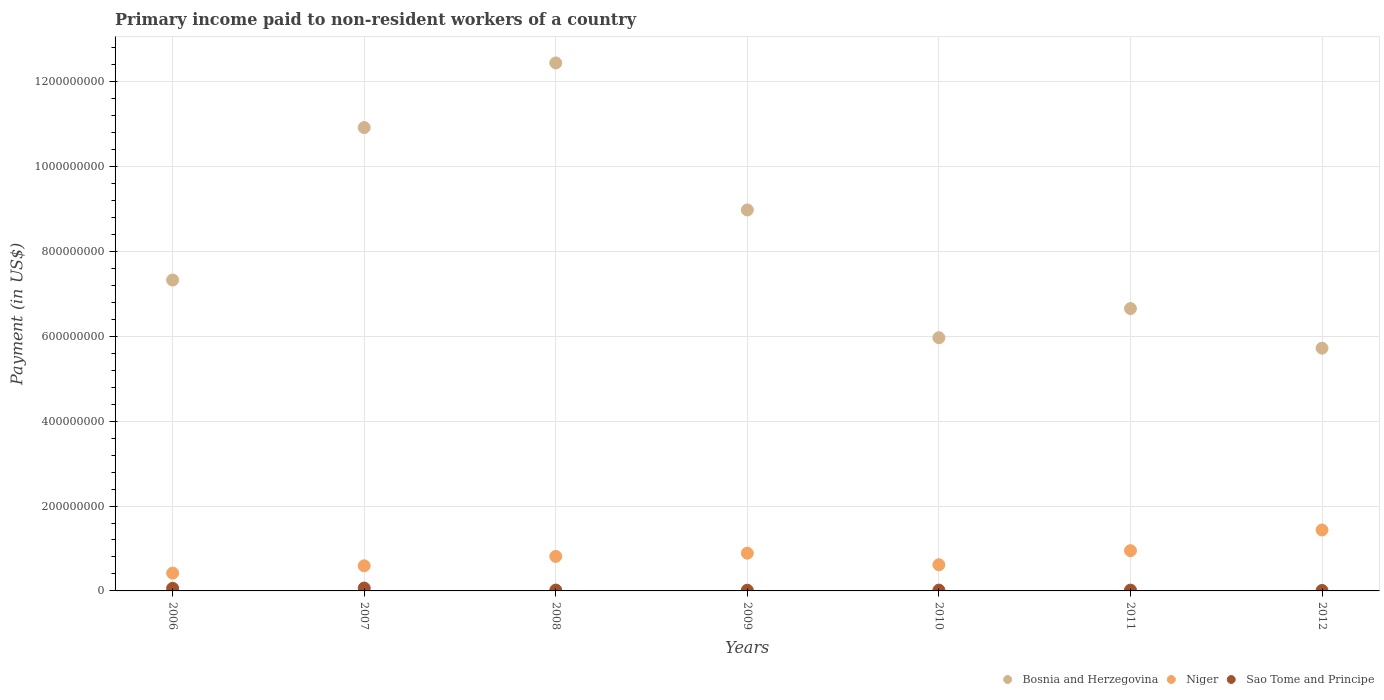How many different coloured dotlines are there?
Your answer should be compact. 3. What is the amount paid to workers in Niger in 2006?
Ensure brevity in your answer.  4.20e+07. Across all years, what is the maximum amount paid to workers in Bosnia and Herzegovina?
Provide a short and direct response. 1.24e+09. Across all years, what is the minimum amount paid to workers in Niger?
Give a very brief answer. 4.20e+07. In which year was the amount paid to workers in Niger minimum?
Make the answer very short. 2006. What is the total amount paid to workers in Bosnia and Herzegovina in the graph?
Your answer should be very brief. 5.80e+09. What is the difference between the amount paid to workers in Niger in 2006 and that in 2011?
Your response must be concise. -5.28e+07. What is the difference between the amount paid to workers in Niger in 2006 and the amount paid to workers in Bosnia and Herzegovina in 2009?
Your answer should be compact. -8.56e+08. What is the average amount paid to workers in Sao Tome and Principe per year?
Your answer should be very brief. 3.04e+06. In the year 2009, what is the difference between the amount paid to workers in Niger and amount paid to workers in Bosnia and Herzegovina?
Provide a succinct answer. -8.09e+08. What is the ratio of the amount paid to workers in Sao Tome and Principe in 2008 to that in 2011?
Make the answer very short. 1.04. Is the difference between the amount paid to workers in Niger in 2009 and 2011 greater than the difference between the amount paid to workers in Bosnia and Herzegovina in 2009 and 2011?
Give a very brief answer. No. What is the difference between the highest and the second highest amount paid to workers in Sao Tome and Principe?
Offer a very short reply. 6.11e+05. What is the difference between the highest and the lowest amount paid to workers in Niger?
Offer a terse response. 1.02e+08. In how many years, is the amount paid to workers in Bosnia and Herzegovina greater than the average amount paid to workers in Bosnia and Herzegovina taken over all years?
Give a very brief answer. 3. Is the sum of the amount paid to workers in Bosnia and Herzegovina in 2007 and 2008 greater than the maximum amount paid to workers in Niger across all years?
Offer a terse response. Yes. Does the graph contain grids?
Ensure brevity in your answer.  Yes. Where does the legend appear in the graph?
Give a very brief answer. Bottom right. How are the legend labels stacked?
Offer a terse response. Horizontal. What is the title of the graph?
Your response must be concise. Primary income paid to non-resident workers of a country. Does "Somalia" appear as one of the legend labels in the graph?
Keep it short and to the point. No. What is the label or title of the X-axis?
Your response must be concise. Years. What is the label or title of the Y-axis?
Offer a terse response. Payment (in US$). What is the Payment (in US$) in Bosnia and Herzegovina in 2006?
Offer a very short reply. 7.33e+08. What is the Payment (in US$) of Niger in 2006?
Offer a terse response. 4.20e+07. What is the Payment (in US$) in Sao Tome and Principe in 2006?
Provide a succinct answer. 6.15e+06. What is the Payment (in US$) in Bosnia and Herzegovina in 2007?
Provide a short and direct response. 1.09e+09. What is the Payment (in US$) in Niger in 2007?
Your answer should be compact. 5.92e+07. What is the Payment (in US$) in Sao Tome and Principe in 2007?
Give a very brief answer. 6.76e+06. What is the Payment (in US$) in Bosnia and Herzegovina in 2008?
Make the answer very short. 1.24e+09. What is the Payment (in US$) of Niger in 2008?
Offer a very short reply. 8.13e+07. What is the Payment (in US$) in Sao Tome and Principe in 2008?
Ensure brevity in your answer.  1.94e+06. What is the Payment (in US$) in Bosnia and Herzegovina in 2009?
Offer a very short reply. 8.98e+08. What is the Payment (in US$) of Niger in 2009?
Give a very brief answer. 8.89e+07. What is the Payment (in US$) of Sao Tome and Principe in 2009?
Your response must be concise. 1.64e+06. What is the Payment (in US$) of Bosnia and Herzegovina in 2010?
Offer a terse response. 5.97e+08. What is the Payment (in US$) of Niger in 2010?
Offer a terse response. 6.17e+07. What is the Payment (in US$) in Sao Tome and Principe in 2010?
Make the answer very short. 1.89e+06. What is the Payment (in US$) in Bosnia and Herzegovina in 2011?
Your answer should be compact. 6.65e+08. What is the Payment (in US$) of Niger in 2011?
Your answer should be very brief. 9.48e+07. What is the Payment (in US$) in Sao Tome and Principe in 2011?
Your answer should be very brief. 1.87e+06. What is the Payment (in US$) in Bosnia and Herzegovina in 2012?
Give a very brief answer. 5.72e+08. What is the Payment (in US$) in Niger in 2012?
Ensure brevity in your answer.  1.44e+08. What is the Payment (in US$) in Sao Tome and Principe in 2012?
Offer a terse response. 1.02e+06. Across all years, what is the maximum Payment (in US$) in Bosnia and Herzegovina?
Offer a terse response. 1.24e+09. Across all years, what is the maximum Payment (in US$) of Niger?
Your response must be concise. 1.44e+08. Across all years, what is the maximum Payment (in US$) in Sao Tome and Principe?
Your answer should be very brief. 6.76e+06. Across all years, what is the minimum Payment (in US$) of Bosnia and Herzegovina?
Your answer should be very brief. 5.72e+08. Across all years, what is the minimum Payment (in US$) of Niger?
Keep it short and to the point. 4.20e+07. Across all years, what is the minimum Payment (in US$) in Sao Tome and Principe?
Ensure brevity in your answer.  1.02e+06. What is the total Payment (in US$) of Bosnia and Herzegovina in the graph?
Your answer should be compact. 5.80e+09. What is the total Payment (in US$) in Niger in the graph?
Offer a very short reply. 5.72e+08. What is the total Payment (in US$) in Sao Tome and Principe in the graph?
Make the answer very short. 2.13e+07. What is the difference between the Payment (in US$) of Bosnia and Herzegovina in 2006 and that in 2007?
Provide a short and direct response. -3.59e+08. What is the difference between the Payment (in US$) of Niger in 2006 and that in 2007?
Provide a succinct answer. -1.72e+07. What is the difference between the Payment (in US$) in Sao Tome and Principe in 2006 and that in 2007?
Offer a terse response. -6.11e+05. What is the difference between the Payment (in US$) of Bosnia and Herzegovina in 2006 and that in 2008?
Your answer should be compact. -5.12e+08. What is the difference between the Payment (in US$) of Niger in 2006 and that in 2008?
Give a very brief answer. -3.94e+07. What is the difference between the Payment (in US$) in Sao Tome and Principe in 2006 and that in 2008?
Ensure brevity in your answer.  4.21e+06. What is the difference between the Payment (in US$) of Bosnia and Herzegovina in 2006 and that in 2009?
Offer a very short reply. -1.65e+08. What is the difference between the Payment (in US$) in Niger in 2006 and that in 2009?
Provide a succinct answer. -4.70e+07. What is the difference between the Payment (in US$) in Sao Tome and Principe in 2006 and that in 2009?
Keep it short and to the point. 4.51e+06. What is the difference between the Payment (in US$) in Bosnia and Herzegovina in 2006 and that in 2010?
Provide a succinct answer. 1.36e+08. What is the difference between the Payment (in US$) in Niger in 2006 and that in 2010?
Offer a terse response. -1.97e+07. What is the difference between the Payment (in US$) in Sao Tome and Principe in 2006 and that in 2010?
Make the answer very short. 4.26e+06. What is the difference between the Payment (in US$) of Bosnia and Herzegovina in 2006 and that in 2011?
Offer a very short reply. 6.72e+07. What is the difference between the Payment (in US$) in Niger in 2006 and that in 2011?
Ensure brevity in your answer.  -5.28e+07. What is the difference between the Payment (in US$) of Sao Tome and Principe in 2006 and that in 2011?
Provide a short and direct response. 4.29e+06. What is the difference between the Payment (in US$) in Bosnia and Herzegovina in 2006 and that in 2012?
Keep it short and to the point. 1.61e+08. What is the difference between the Payment (in US$) in Niger in 2006 and that in 2012?
Your answer should be very brief. -1.02e+08. What is the difference between the Payment (in US$) in Sao Tome and Principe in 2006 and that in 2012?
Offer a terse response. 5.13e+06. What is the difference between the Payment (in US$) of Bosnia and Herzegovina in 2007 and that in 2008?
Ensure brevity in your answer.  -1.52e+08. What is the difference between the Payment (in US$) in Niger in 2007 and that in 2008?
Provide a succinct answer. -2.22e+07. What is the difference between the Payment (in US$) in Sao Tome and Principe in 2007 and that in 2008?
Offer a very short reply. 4.83e+06. What is the difference between the Payment (in US$) in Bosnia and Herzegovina in 2007 and that in 2009?
Your response must be concise. 1.94e+08. What is the difference between the Payment (in US$) in Niger in 2007 and that in 2009?
Keep it short and to the point. -2.98e+07. What is the difference between the Payment (in US$) of Sao Tome and Principe in 2007 and that in 2009?
Ensure brevity in your answer.  5.12e+06. What is the difference between the Payment (in US$) in Bosnia and Herzegovina in 2007 and that in 2010?
Provide a succinct answer. 4.95e+08. What is the difference between the Payment (in US$) in Niger in 2007 and that in 2010?
Your answer should be compact. -2.50e+06. What is the difference between the Payment (in US$) of Sao Tome and Principe in 2007 and that in 2010?
Your response must be concise. 4.87e+06. What is the difference between the Payment (in US$) in Bosnia and Herzegovina in 2007 and that in 2011?
Your answer should be compact. 4.27e+08. What is the difference between the Payment (in US$) of Niger in 2007 and that in 2011?
Offer a terse response. -3.56e+07. What is the difference between the Payment (in US$) of Sao Tome and Principe in 2007 and that in 2011?
Offer a terse response. 4.90e+06. What is the difference between the Payment (in US$) of Bosnia and Herzegovina in 2007 and that in 2012?
Provide a short and direct response. 5.20e+08. What is the difference between the Payment (in US$) of Niger in 2007 and that in 2012?
Provide a succinct answer. -8.44e+07. What is the difference between the Payment (in US$) of Sao Tome and Principe in 2007 and that in 2012?
Offer a terse response. 5.74e+06. What is the difference between the Payment (in US$) in Bosnia and Herzegovina in 2008 and that in 2009?
Your answer should be compact. 3.46e+08. What is the difference between the Payment (in US$) of Niger in 2008 and that in 2009?
Provide a short and direct response. -7.60e+06. What is the difference between the Payment (in US$) of Sao Tome and Principe in 2008 and that in 2009?
Offer a terse response. 2.96e+05. What is the difference between the Payment (in US$) of Bosnia and Herzegovina in 2008 and that in 2010?
Make the answer very short. 6.47e+08. What is the difference between the Payment (in US$) of Niger in 2008 and that in 2010?
Offer a terse response. 1.96e+07. What is the difference between the Payment (in US$) in Sao Tome and Principe in 2008 and that in 2010?
Provide a succinct answer. 4.46e+04. What is the difference between the Payment (in US$) in Bosnia and Herzegovina in 2008 and that in 2011?
Your response must be concise. 5.79e+08. What is the difference between the Payment (in US$) in Niger in 2008 and that in 2011?
Ensure brevity in your answer.  -1.35e+07. What is the difference between the Payment (in US$) in Sao Tome and Principe in 2008 and that in 2011?
Make the answer very short. 7.24e+04. What is the difference between the Payment (in US$) in Bosnia and Herzegovina in 2008 and that in 2012?
Provide a succinct answer. 6.72e+08. What is the difference between the Payment (in US$) of Niger in 2008 and that in 2012?
Your answer should be very brief. -6.23e+07. What is the difference between the Payment (in US$) in Sao Tome and Principe in 2008 and that in 2012?
Your answer should be compact. 9.18e+05. What is the difference between the Payment (in US$) of Bosnia and Herzegovina in 2009 and that in 2010?
Provide a short and direct response. 3.01e+08. What is the difference between the Payment (in US$) in Niger in 2009 and that in 2010?
Give a very brief answer. 2.73e+07. What is the difference between the Payment (in US$) in Sao Tome and Principe in 2009 and that in 2010?
Offer a very short reply. -2.51e+05. What is the difference between the Payment (in US$) in Bosnia and Herzegovina in 2009 and that in 2011?
Provide a short and direct response. 2.32e+08. What is the difference between the Payment (in US$) of Niger in 2009 and that in 2011?
Your response must be concise. -5.86e+06. What is the difference between the Payment (in US$) of Sao Tome and Principe in 2009 and that in 2011?
Your answer should be compact. -2.24e+05. What is the difference between the Payment (in US$) in Bosnia and Herzegovina in 2009 and that in 2012?
Offer a very short reply. 3.26e+08. What is the difference between the Payment (in US$) of Niger in 2009 and that in 2012?
Keep it short and to the point. -5.47e+07. What is the difference between the Payment (in US$) in Sao Tome and Principe in 2009 and that in 2012?
Your answer should be very brief. 6.22e+05. What is the difference between the Payment (in US$) in Bosnia and Herzegovina in 2010 and that in 2011?
Give a very brief answer. -6.87e+07. What is the difference between the Payment (in US$) of Niger in 2010 and that in 2011?
Keep it short and to the point. -3.31e+07. What is the difference between the Payment (in US$) of Sao Tome and Principe in 2010 and that in 2011?
Keep it short and to the point. 2.78e+04. What is the difference between the Payment (in US$) in Bosnia and Herzegovina in 2010 and that in 2012?
Your answer should be compact. 2.46e+07. What is the difference between the Payment (in US$) in Niger in 2010 and that in 2012?
Provide a short and direct response. -8.19e+07. What is the difference between the Payment (in US$) of Sao Tome and Principe in 2010 and that in 2012?
Give a very brief answer. 8.74e+05. What is the difference between the Payment (in US$) of Bosnia and Herzegovina in 2011 and that in 2012?
Provide a short and direct response. 9.33e+07. What is the difference between the Payment (in US$) of Niger in 2011 and that in 2012?
Keep it short and to the point. -4.88e+07. What is the difference between the Payment (in US$) of Sao Tome and Principe in 2011 and that in 2012?
Provide a short and direct response. 8.46e+05. What is the difference between the Payment (in US$) in Bosnia and Herzegovina in 2006 and the Payment (in US$) in Niger in 2007?
Provide a succinct answer. 6.73e+08. What is the difference between the Payment (in US$) of Bosnia and Herzegovina in 2006 and the Payment (in US$) of Sao Tome and Principe in 2007?
Offer a terse response. 7.26e+08. What is the difference between the Payment (in US$) in Niger in 2006 and the Payment (in US$) in Sao Tome and Principe in 2007?
Make the answer very short. 3.52e+07. What is the difference between the Payment (in US$) in Bosnia and Herzegovina in 2006 and the Payment (in US$) in Niger in 2008?
Keep it short and to the point. 6.51e+08. What is the difference between the Payment (in US$) of Bosnia and Herzegovina in 2006 and the Payment (in US$) of Sao Tome and Principe in 2008?
Keep it short and to the point. 7.31e+08. What is the difference between the Payment (in US$) of Niger in 2006 and the Payment (in US$) of Sao Tome and Principe in 2008?
Provide a short and direct response. 4.00e+07. What is the difference between the Payment (in US$) of Bosnia and Herzegovina in 2006 and the Payment (in US$) of Niger in 2009?
Offer a very short reply. 6.44e+08. What is the difference between the Payment (in US$) of Bosnia and Herzegovina in 2006 and the Payment (in US$) of Sao Tome and Principe in 2009?
Provide a short and direct response. 7.31e+08. What is the difference between the Payment (in US$) in Niger in 2006 and the Payment (in US$) in Sao Tome and Principe in 2009?
Give a very brief answer. 4.03e+07. What is the difference between the Payment (in US$) in Bosnia and Herzegovina in 2006 and the Payment (in US$) in Niger in 2010?
Your answer should be very brief. 6.71e+08. What is the difference between the Payment (in US$) of Bosnia and Herzegovina in 2006 and the Payment (in US$) of Sao Tome and Principe in 2010?
Provide a succinct answer. 7.31e+08. What is the difference between the Payment (in US$) of Niger in 2006 and the Payment (in US$) of Sao Tome and Principe in 2010?
Offer a terse response. 4.01e+07. What is the difference between the Payment (in US$) of Bosnia and Herzegovina in 2006 and the Payment (in US$) of Niger in 2011?
Provide a short and direct response. 6.38e+08. What is the difference between the Payment (in US$) of Bosnia and Herzegovina in 2006 and the Payment (in US$) of Sao Tome and Principe in 2011?
Keep it short and to the point. 7.31e+08. What is the difference between the Payment (in US$) of Niger in 2006 and the Payment (in US$) of Sao Tome and Principe in 2011?
Offer a very short reply. 4.01e+07. What is the difference between the Payment (in US$) of Bosnia and Herzegovina in 2006 and the Payment (in US$) of Niger in 2012?
Provide a succinct answer. 5.89e+08. What is the difference between the Payment (in US$) in Bosnia and Herzegovina in 2006 and the Payment (in US$) in Sao Tome and Principe in 2012?
Provide a succinct answer. 7.32e+08. What is the difference between the Payment (in US$) of Niger in 2006 and the Payment (in US$) of Sao Tome and Principe in 2012?
Give a very brief answer. 4.10e+07. What is the difference between the Payment (in US$) in Bosnia and Herzegovina in 2007 and the Payment (in US$) in Niger in 2008?
Make the answer very short. 1.01e+09. What is the difference between the Payment (in US$) in Bosnia and Herzegovina in 2007 and the Payment (in US$) in Sao Tome and Principe in 2008?
Your answer should be very brief. 1.09e+09. What is the difference between the Payment (in US$) in Niger in 2007 and the Payment (in US$) in Sao Tome and Principe in 2008?
Offer a very short reply. 5.72e+07. What is the difference between the Payment (in US$) in Bosnia and Herzegovina in 2007 and the Payment (in US$) in Niger in 2009?
Offer a very short reply. 1.00e+09. What is the difference between the Payment (in US$) in Bosnia and Herzegovina in 2007 and the Payment (in US$) in Sao Tome and Principe in 2009?
Provide a succinct answer. 1.09e+09. What is the difference between the Payment (in US$) in Niger in 2007 and the Payment (in US$) in Sao Tome and Principe in 2009?
Your answer should be very brief. 5.75e+07. What is the difference between the Payment (in US$) in Bosnia and Herzegovina in 2007 and the Payment (in US$) in Niger in 2010?
Ensure brevity in your answer.  1.03e+09. What is the difference between the Payment (in US$) in Bosnia and Herzegovina in 2007 and the Payment (in US$) in Sao Tome and Principe in 2010?
Make the answer very short. 1.09e+09. What is the difference between the Payment (in US$) of Niger in 2007 and the Payment (in US$) of Sao Tome and Principe in 2010?
Make the answer very short. 5.73e+07. What is the difference between the Payment (in US$) of Bosnia and Herzegovina in 2007 and the Payment (in US$) of Niger in 2011?
Make the answer very short. 9.97e+08. What is the difference between the Payment (in US$) of Bosnia and Herzegovina in 2007 and the Payment (in US$) of Sao Tome and Principe in 2011?
Provide a succinct answer. 1.09e+09. What is the difference between the Payment (in US$) in Niger in 2007 and the Payment (in US$) in Sao Tome and Principe in 2011?
Your answer should be compact. 5.73e+07. What is the difference between the Payment (in US$) in Bosnia and Herzegovina in 2007 and the Payment (in US$) in Niger in 2012?
Provide a short and direct response. 9.48e+08. What is the difference between the Payment (in US$) of Bosnia and Herzegovina in 2007 and the Payment (in US$) of Sao Tome and Principe in 2012?
Keep it short and to the point. 1.09e+09. What is the difference between the Payment (in US$) in Niger in 2007 and the Payment (in US$) in Sao Tome and Principe in 2012?
Your answer should be compact. 5.82e+07. What is the difference between the Payment (in US$) of Bosnia and Herzegovina in 2008 and the Payment (in US$) of Niger in 2009?
Your answer should be very brief. 1.16e+09. What is the difference between the Payment (in US$) of Bosnia and Herzegovina in 2008 and the Payment (in US$) of Sao Tome and Principe in 2009?
Offer a terse response. 1.24e+09. What is the difference between the Payment (in US$) of Niger in 2008 and the Payment (in US$) of Sao Tome and Principe in 2009?
Provide a succinct answer. 7.97e+07. What is the difference between the Payment (in US$) in Bosnia and Herzegovina in 2008 and the Payment (in US$) in Niger in 2010?
Provide a short and direct response. 1.18e+09. What is the difference between the Payment (in US$) in Bosnia and Herzegovina in 2008 and the Payment (in US$) in Sao Tome and Principe in 2010?
Provide a short and direct response. 1.24e+09. What is the difference between the Payment (in US$) of Niger in 2008 and the Payment (in US$) of Sao Tome and Principe in 2010?
Provide a short and direct response. 7.94e+07. What is the difference between the Payment (in US$) in Bosnia and Herzegovina in 2008 and the Payment (in US$) in Niger in 2011?
Make the answer very short. 1.15e+09. What is the difference between the Payment (in US$) of Bosnia and Herzegovina in 2008 and the Payment (in US$) of Sao Tome and Principe in 2011?
Keep it short and to the point. 1.24e+09. What is the difference between the Payment (in US$) of Niger in 2008 and the Payment (in US$) of Sao Tome and Principe in 2011?
Your answer should be very brief. 7.95e+07. What is the difference between the Payment (in US$) in Bosnia and Herzegovina in 2008 and the Payment (in US$) in Niger in 2012?
Provide a succinct answer. 1.10e+09. What is the difference between the Payment (in US$) in Bosnia and Herzegovina in 2008 and the Payment (in US$) in Sao Tome and Principe in 2012?
Offer a very short reply. 1.24e+09. What is the difference between the Payment (in US$) in Niger in 2008 and the Payment (in US$) in Sao Tome and Principe in 2012?
Offer a terse response. 8.03e+07. What is the difference between the Payment (in US$) in Bosnia and Herzegovina in 2009 and the Payment (in US$) in Niger in 2010?
Your answer should be very brief. 8.36e+08. What is the difference between the Payment (in US$) of Bosnia and Herzegovina in 2009 and the Payment (in US$) of Sao Tome and Principe in 2010?
Your response must be concise. 8.96e+08. What is the difference between the Payment (in US$) of Niger in 2009 and the Payment (in US$) of Sao Tome and Principe in 2010?
Provide a succinct answer. 8.70e+07. What is the difference between the Payment (in US$) of Bosnia and Herzegovina in 2009 and the Payment (in US$) of Niger in 2011?
Provide a short and direct response. 8.03e+08. What is the difference between the Payment (in US$) in Bosnia and Herzegovina in 2009 and the Payment (in US$) in Sao Tome and Principe in 2011?
Provide a short and direct response. 8.96e+08. What is the difference between the Payment (in US$) of Niger in 2009 and the Payment (in US$) of Sao Tome and Principe in 2011?
Keep it short and to the point. 8.71e+07. What is the difference between the Payment (in US$) of Bosnia and Herzegovina in 2009 and the Payment (in US$) of Niger in 2012?
Offer a terse response. 7.54e+08. What is the difference between the Payment (in US$) in Bosnia and Herzegovina in 2009 and the Payment (in US$) in Sao Tome and Principe in 2012?
Your answer should be very brief. 8.97e+08. What is the difference between the Payment (in US$) in Niger in 2009 and the Payment (in US$) in Sao Tome and Principe in 2012?
Keep it short and to the point. 8.79e+07. What is the difference between the Payment (in US$) of Bosnia and Herzegovina in 2010 and the Payment (in US$) of Niger in 2011?
Make the answer very short. 5.02e+08. What is the difference between the Payment (in US$) in Bosnia and Herzegovina in 2010 and the Payment (in US$) in Sao Tome and Principe in 2011?
Ensure brevity in your answer.  5.95e+08. What is the difference between the Payment (in US$) of Niger in 2010 and the Payment (in US$) of Sao Tome and Principe in 2011?
Your answer should be very brief. 5.98e+07. What is the difference between the Payment (in US$) in Bosnia and Herzegovina in 2010 and the Payment (in US$) in Niger in 2012?
Keep it short and to the point. 4.53e+08. What is the difference between the Payment (in US$) of Bosnia and Herzegovina in 2010 and the Payment (in US$) of Sao Tome and Principe in 2012?
Your response must be concise. 5.96e+08. What is the difference between the Payment (in US$) of Niger in 2010 and the Payment (in US$) of Sao Tome and Principe in 2012?
Offer a terse response. 6.07e+07. What is the difference between the Payment (in US$) of Bosnia and Herzegovina in 2011 and the Payment (in US$) of Niger in 2012?
Offer a terse response. 5.22e+08. What is the difference between the Payment (in US$) in Bosnia and Herzegovina in 2011 and the Payment (in US$) in Sao Tome and Principe in 2012?
Your response must be concise. 6.64e+08. What is the difference between the Payment (in US$) of Niger in 2011 and the Payment (in US$) of Sao Tome and Principe in 2012?
Offer a terse response. 9.38e+07. What is the average Payment (in US$) in Bosnia and Herzegovina per year?
Your answer should be very brief. 8.29e+08. What is the average Payment (in US$) in Niger per year?
Make the answer very short. 8.17e+07. What is the average Payment (in US$) in Sao Tome and Principe per year?
Keep it short and to the point. 3.04e+06. In the year 2006, what is the difference between the Payment (in US$) of Bosnia and Herzegovina and Payment (in US$) of Niger?
Your response must be concise. 6.91e+08. In the year 2006, what is the difference between the Payment (in US$) in Bosnia and Herzegovina and Payment (in US$) in Sao Tome and Principe?
Your answer should be compact. 7.26e+08. In the year 2006, what is the difference between the Payment (in US$) in Niger and Payment (in US$) in Sao Tome and Principe?
Your response must be concise. 3.58e+07. In the year 2007, what is the difference between the Payment (in US$) in Bosnia and Herzegovina and Payment (in US$) in Niger?
Give a very brief answer. 1.03e+09. In the year 2007, what is the difference between the Payment (in US$) in Bosnia and Herzegovina and Payment (in US$) in Sao Tome and Principe?
Your answer should be very brief. 1.09e+09. In the year 2007, what is the difference between the Payment (in US$) of Niger and Payment (in US$) of Sao Tome and Principe?
Provide a short and direct response. 5.24e+07. In the year 2008, what is the difference between the Payment (in US$) of Bosnia and Herzegovina and Payment (in US$) of Niger?
Keep it short and to the point. 1.16e+09. In the year 2008, what is the difference between the Payment (in US$) of Bosnia and Herzegovina and Payment (in US$) of Sao Tome and Principe?
Keep it short and to the point. 1.24e+09. In the year 2008, what is the difference between the Payment (in US$) in Niger and Payment (in US$) in Sao Tome and Principe?
Make the answer very short. 7.94e+07. In the year 2009, what is the difference between the Payment (in US$) in Bosnia and Herzegovina and Payment (in US$) in Niger?
Give a very brief answer. 8.09e+08. In the year 2009, what is the difference between the Payment (in US$) of Bosnia and Herzegovina and Payment (in US$) of Sao Tome and Principe?
Your response must be concise. 8.96e+08. In the year 2009, what is the difference between the Payment (in US$) in Niger and Payment (in US$) in Sao Tome and Principe?
Your response must be concise. 8.73e+07. In the year 2010, what is the difference between the Payment (in US$) in Bosnia and Herzegovina and Payment (in US$) in Niger?
Make the answer very short. 5.35e+08. In the year 2010, what is the difference between the Payment (in US$) in Bosnia and Herzegovina and Payment (in US$) in Sao Tome and Principe?
Offer a very short reply. 5.95e+08. In the year 2010, what is the difference between the Payment (in US$) in Niger and Payment (in US$) in Sao Tome and Principe?
Give a very brief answer. 5.98e+07. In the year 2011, what is the difference between the Payment (in US$) in Bosnia and Herzegovina and Payment (in US$) in Niger?
Ensure brevity in your answer.  5.71e+08. In the year 2011, what is the difference between the Payment (in US$) in Bosnia and Herzegovina and Payment (in US$) in Sao Tome and Principe?
Make the answer very short. 6.63e+08. In the year 2011, what is the difference between the Payment (in US$) of Niger and Payment (in US$) of Sao Tome and Principe?
Ensure brevity in your answer.  9.29e+07. In the year 2012, what is the difference between the Payment (in US$) of Bosnia and Herzegovina and Payment (in US$) of Niger?
Your answer should be compact. 4.28e+08. In the year 2012, what is the difference between the Payment (in US$) of Bosnia and Herzegovina and Payment (in US$) of Sao Tome and Principe?
Make the answer very short. 5.71e+08. In the year 2012, what is the difference between the Payment (in US$) of Niger and Payment (in US$) of Sao Tome and Principe?
Provide a succinct answer. 1.43e+08. What is the ratio of the Payment (in US$) of Bosnia and Herzegovina in 2006 to that in 2007?
Your response must be concise. 0.67. What is the ratio of the Payment (in US$) in Niger in 2006 to that in 2007?
Keep it short and to the point. 0.71. What is the ratio of the Payment (in US$) of Sao Tome and Principe in 2006 to that in 2007?
Provide a succinct answer. 0.91. What is the ratio of the Payment (in US$) in Bosnia and Herzegovina in 2006 to that in 2008?
Your response must be concise. 0.59. What is the ratio of the Payment (in US$) of Niger in 2006 to that in 2008?
Your answer should be compact. 0.52. What is the ratio of the Payment (in US$) in Sao Tome and Principe in 2006 to that in 2008?
Offer a terse response. 3.17. What is the ratio of the Payment (in US$) in Bosnia and Herzegovina in 2006 to that in 2009?
Offer a terse response. 0.82. What is the ratio of the Payment (in US$) of Niger in 2006 to that in 2009?
Your response must be concise. 0.47. What is the ratio of the Payment (in US$) in Sao Tome and Principe in 2006 to that in 2009?
Ensure brevity in your answer.  3.74. What is the ratio of the Payment (in US$) in Bosnia and Herzegovina in 2006 to that in 2010?
Give a very brief answer. 1.23. What is the ratio of the Payment (in US$) of Niger in 2006 to that in 2010?
Give a very brief answer. 0.68. What is the ratio of the Payment (in US$) in Sao Tome and Principe in 2006 to that in 2010?
Give a very brief answer. 3.25. What is the ratio of the Payment (in US$) of Bosnia and Herzegovina in 2006 to that in 2011?
Your response must be concise. 1.1. What is the ratio of the Payment (in US$) of Niger in 2006 to that in 2011?
Make the answer very short. 0.44. What is the ratio of the Payment (in US$) in Sao Tome and Principe in 2006 to that in 2011?
Keep it short and to the point. 3.3. What is the ratio of the Payment (in US$) of Bosnia and Herzegovina in 2006 to that in 2012?
Ensure brevity in your answer.  1.28. What is the ratio of the Payment (in US$) in Niger in 2006 to that in 2012?
Give a very brief answer. 0.29. What is the ratio of the Payment (in US$) in Sao Tome and Principe in 2006 to that in 2012?
Keep it short and to the point. 6.03. What is the ratio of the Payment (in US$) of Bosnia and Herzegovina in 2007 to that in 2008?
Your answer should be very brief. 0.88. What is the ratio of the Payment (in US$) of Niger in 2007 to that in 2008?
Give a very brief answer. 0.73. What is the ratio of the Payment (in US$) in Sao Tome and Principe in 2007 to that in 2008?
Offer a very short reply. 3.49. What is the ratio of the Payment (in US$) in Bosnia and Herzegovina in 2007 to that in 2009?
Ensure brevity in your answer.  1.22. What is the ratio of the Payment (in US$) of Niger in 2007 to that in 2009?
Ensure brevity in your answer.  0.67. What is the ratio of the Payment (in US$) in Sao Tome and Principe in 2007 to that in 2009?
Make the answer very short. 4.12. What is the ratio of the Payment (in US$) of Bosnia and Herzegovina in 2007 to that in 2010?
Your answer should be very brief. 1.83. What is the ratio of the Payment (in US$) of Niger in 2007 to that in 2010?
Your answer should be very brief. 0.96. What is the ratio of the Payment (in US$) in Sao Tome and Principe in 2007 to that in 2010?
Offer a terse response. 3.57. What is the ratio of the Payment (in US$) in Bosnia and Herzegovina in 2007 to that in 2011?
Keep it short and to the point. 1.64. What is the ratio of the Payment (in US$) in Niger in 2007 to that in 2011?
Keep it short and to the point. 0.62. What is the ratio of the Payment (in US$) in Sao Tome and Principe in 2007 to that in 2011?
Offer a very short reply. 3.62. What is the ratio of the Payment (in US$) in Bosnia and Herzegovina in 2007 to that in 2012?
Your answer should be compact. 1.91. What is the ratio of the Payment (in US$) of Niger in 2007 to that in 2012?
Make the answer very short. 0.41. What is the ratio of the Payment (in US$) in Sao Tome and Principe in 2007 to that in 2012?
Provide a succinct answer. 6.63. What is the ratio of the Payment (in US$) in Bosnia and Herzegovina in 2008 to that in 2009?
Your response must be concise. 1.39. What is the ratio of the Payment (in US$) of Niger in 2008 to that in 2009?
Your answer should be very brief. 0.91. What is the ratio of the Payment (in US$) in Sao Tome and Principe in 2008 to that in 2009?
Offer a terse response. 1.18. What is the ratio of the Payment (in US$) of Bosnia and Herzegovina in 2008 to that in 2010?
Make the answer very short. 2.09. What is the ratio of the Payment (in US$) in Niger in 2008 to that in 2010?
Your response must be concise. 1.32. What is the ratio of the Payment (in US$) of Sao Tome and Principe in 2008 to that in 2010?
Ensure brevity in your answer.  1.02. What is the ratio of the Payment (in US$) in Bosnia and Herzegovina in 2008 to that in 2011?
Provide a succinct answer. 1.87. What is the ratio of the Payment (in US$) in Niger in 2008 to that in 2011?
Your answer should be compact. 0.86. What is the ratio of the Payment (in US$) of Sao Tome and Principe in 2008 to that in 2011?
Provide a short and direct response. 1.04. What is the ratio of the Payment (in US$) in Bosnia and Herzegovina in 2008 to that in 2012?
Your response must be concise. 2.17. What is the ratio of the Payment (in US$) of Niger in 2008 to that in 2012?
Give a very brief answer. 0.57. What is the ratio of the Payment (in US$) in Sao Tome and Principe in 2008 to that in 2012?
Offer a terse response. 1.9. What is the ratio of the Payment (in US$) of Bosnia and Herzegovina in 2009 to that in 2010?
Offer a very short reply. 1.5. What is the ratio of the Payment (in US$) in Niger in 2009 to that in 2010?
Offer a very short reply. 1.44. What is the ratio of the Payment (in US$) in Sao Tome and Principe in 2009 to that in 2010?
Offer a very short reply. 0.87. What is the ratio of the Payment (in US$) of Bosnia and Herzegovina in 2009 to that in 2011?
Your response must be concise. 1.35. What is the ratio of the Payment (in US$) in Niger in 2009 to that in 2011?
Make the answer very short. 0.94. What is the ratio of the Payment (in US$) of Sao Tome and Principe in 2009 to that in 2011?
Give a very brief answer. 0.88. What is the ratio of the Payment (in US$) of Bosnia and Herzegovina in 2009 to that in 2012?
Give a very brief answer. 1.57. What is the ratio of the Payment (in US$) in Niger in 2009 to that in 2012?
Provide a short and direct response. 0.62. What is the ratio of the Payment (in US$) of Sao Tome and Principe in 2009 to that in 2012?
Make the answer very short. 1.61. What is the ratio of the Payment (in US$) in Bosnia and Herzegovina in 2010 to that in 2011?
Provide a short and direct response. 0.9. What is the ratio of the Payment (in US$) in Niger in 2010 to that in 2011?
Your answer should be compact. 0.65. What is the ratio of the Payment (in US$) in Sao Tome and Principe in 2010 to that in 2011?
Your answer should be compact. 1.01. What is the ratio of the Payment (in US$) in Bosnia and Herzegovina in 2010 to that in 2012?
Your answer should be very brief. 1.04. What is the ratio of the Payment (in US$) in Niger in 2010 to that in 2012?
Keep it short and to the point. 0.43. What is the ratio of the Payment (in US$) of Sao Tome and Principe in 2010 to that in 2012?
Provide a succinct answer. 1.86. What is the ratio of the Payment (in US$) of Bosnia and Herzegovina in 2011 to that in 2012?
Offer a terse response. 1.16. What is the ratio of the Payment (in US$) of Niger in 2011 to that in 2012?
Provide a short and direct response. 0.66. What is the ratio of the Payment (in US$) in Sao Tome and Principe in 2011 to that in 2012?
Make the answer very short. 1.83. What is the difference between the highest and the second highest Payment (in US$) of Bosnia and Herzegovina?
Provide a succinct answer. 1.52e+08. What is the difference between the highest and the second highest Payment (in US$) of Niger?
Offer a very short reply. 4.88e+07. What is the difference between the highest and the second highest Payment (in US$) of Sao Tome and Principe?
Your answer should be compact. 6.11e+05. What is the difference between the highest and the lowest Payment (in US$) of Bosnia and Herzegovina?
Ensure brevity in your answer.  6.72e+08. What is the difference between the highest and the lowest Payment (in US$) of Niger?
Provide a short and direct response. 1.02e+08. What is the difference between the highest and the lowest Payment (in US$) in Sao Tome and Principe?
Your response must be concise. 5.74e+06. 